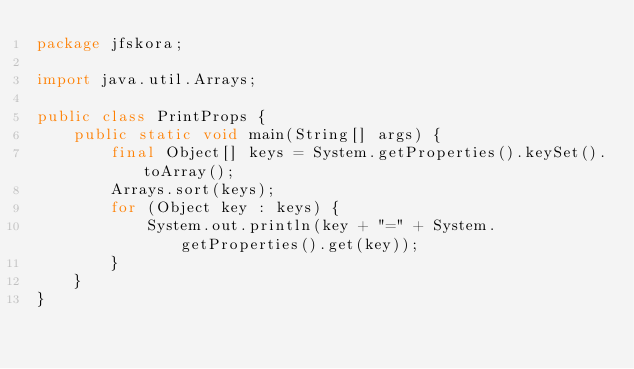<code> <loc_0><loc_0><loc_500><loc_500><_Java_>package jfskora;

import java.util.Arrays;

public class PrintProps {
    public static void main(String[] args) {
        final Object[] keys = System.getProperties().keySet().toArray();
        Arrays.sort(keys);
        for (Object key : keys) {
            System.out.println(key + "=" + System.getProperties().get(key));
        }
    }
}</code> 